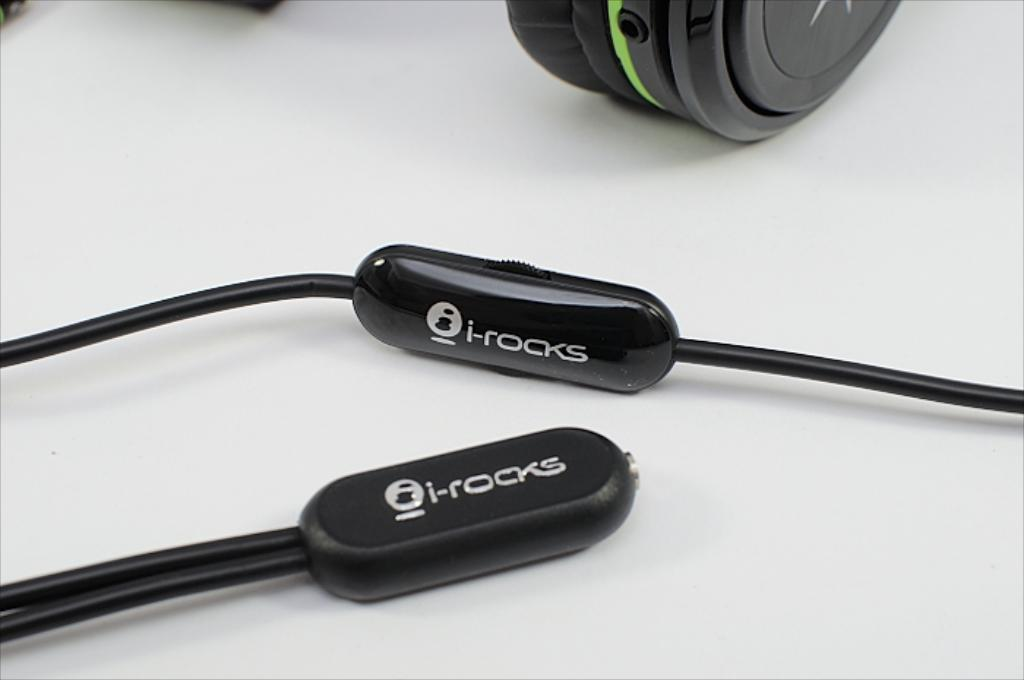Provide a one-sentence caption for the provided image. i-rocks headphones are displayed on their side so that the logo is seen. 